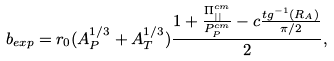Convert formula to latex. <formula><loc_0><loc_0><loc_500><loc_500>b _ { e x p } = r _ { 0 } ( A _ { P } ^ { 1 / 3 } + A _ { T } ^ { 1 / 3 } ) \frac { 1 + \frac { \Pi _ { | | } ^ { c m } } { P _ { P } ^ { c m } } - c \frac { t g ^ { - 1 } ( R _ { A } ) } { \pi / 2 } } { 2 } ,</formula> 